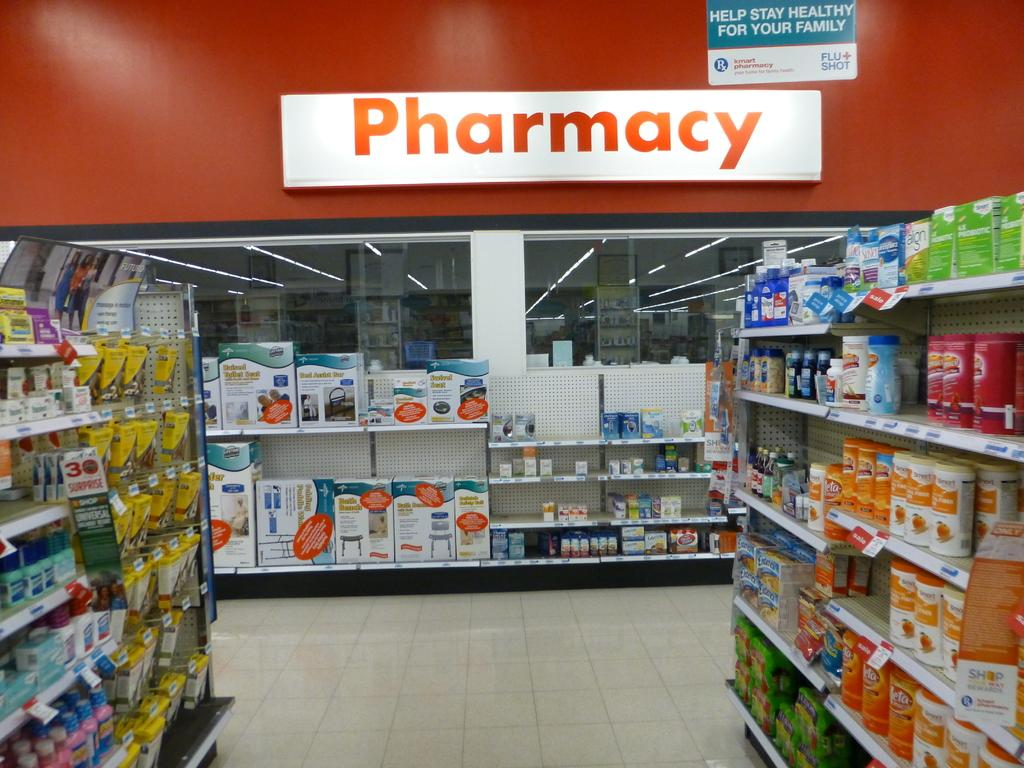<image>
Describe the image concisely. The inside of a store of merchandise with a large pharmacy sign. 